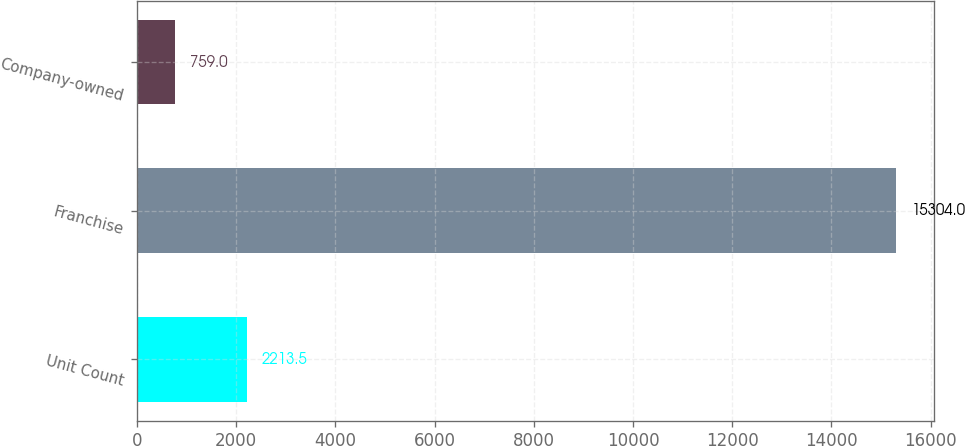<chart> <loc_0><loc_0><loc_500><loc_500><bar_chart><fcel>Unit Count<fcel>Franchise<fcel>Company-owned<nl><fcel>2213.5<fcel>15304<fcel>759<nl></chart> 